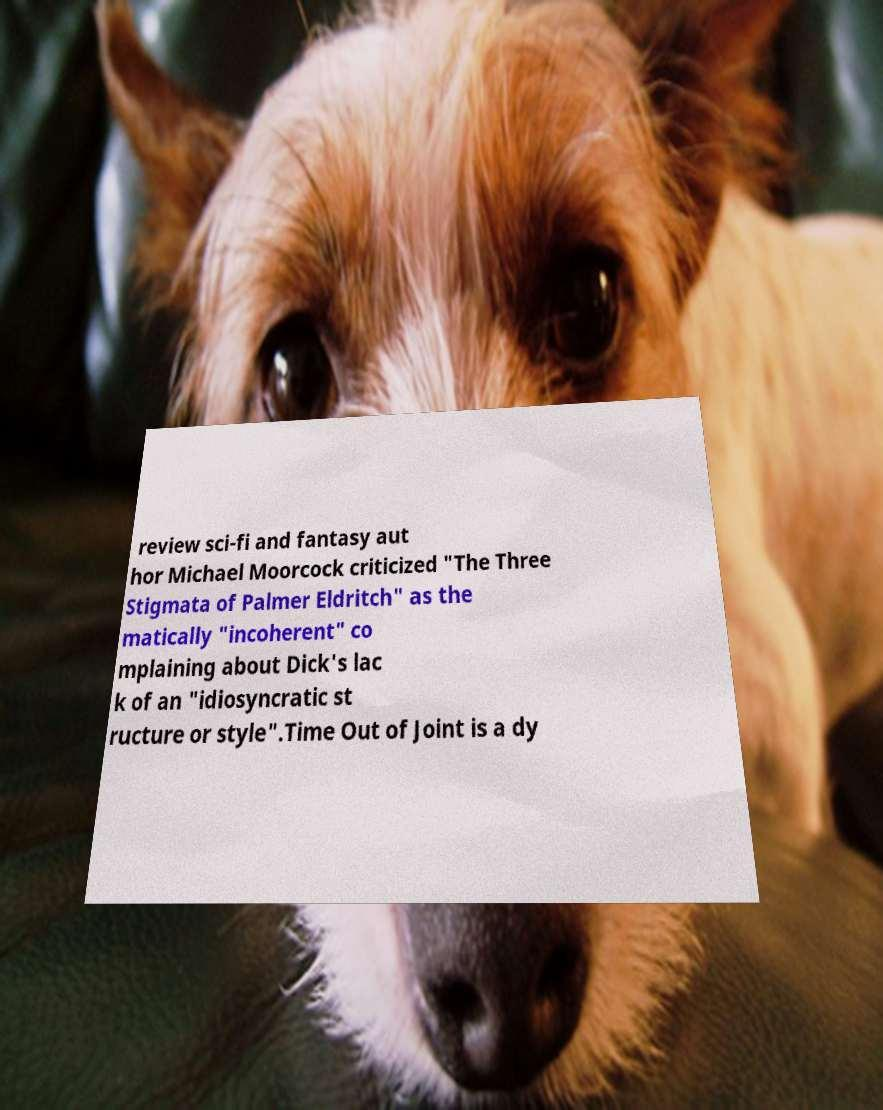What messages or text are displayed in this image? I need them in a readable, typed format. review sci-fi and fantasy aut hor Michael Moorcock criticized "The Three Stigmata of Palmer Eldritch" as the matically "incoherent" co mplaining about Dick's lac k of an "idiosyncratic st ructure or style".Time Out of Joint is a dy 